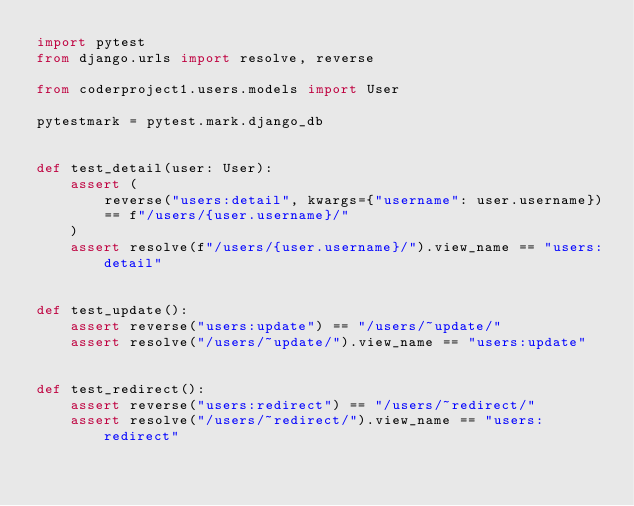Convert code to text. <code><loc_0><loc_0><loc_500><loc_500><_Python_>import pytest
from django.urls import resolve, reverse

from coderproject1.users.models import User

pytestmark = pytest.mark.django_db


def test_detail(user: User):
    assert (
        reverse("users:detail", kwargs={"username": user.username})
        == f"/users/{user.username}/"
    )
    assert resolve(f"/users/{user.username}/").view_name == "users:detail"


def test_update():
    assert reverse("users:update") == "/users/~update/"
    assert resolve("/users/~update/").view_name == "users:update"


def test_redirect():
    assert reverse("users:redirect") == "/users/~redirect/"
    assert resolve("/users/~redirect/").view_name == "users:redirect"
</code> 